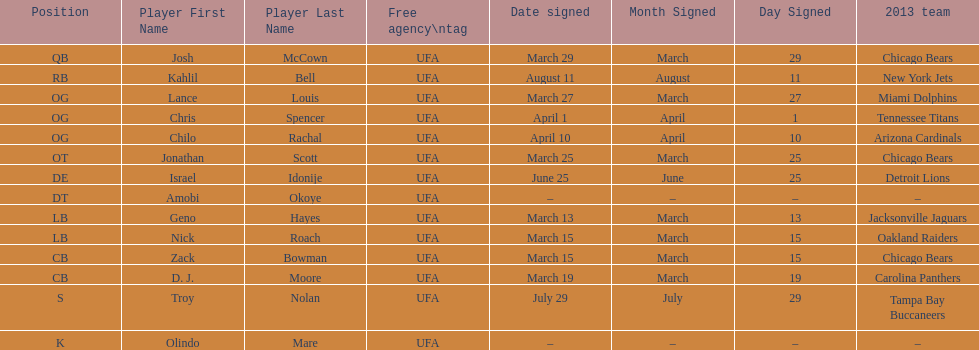Signed the same date as "april fools day". Chris Spencer. 